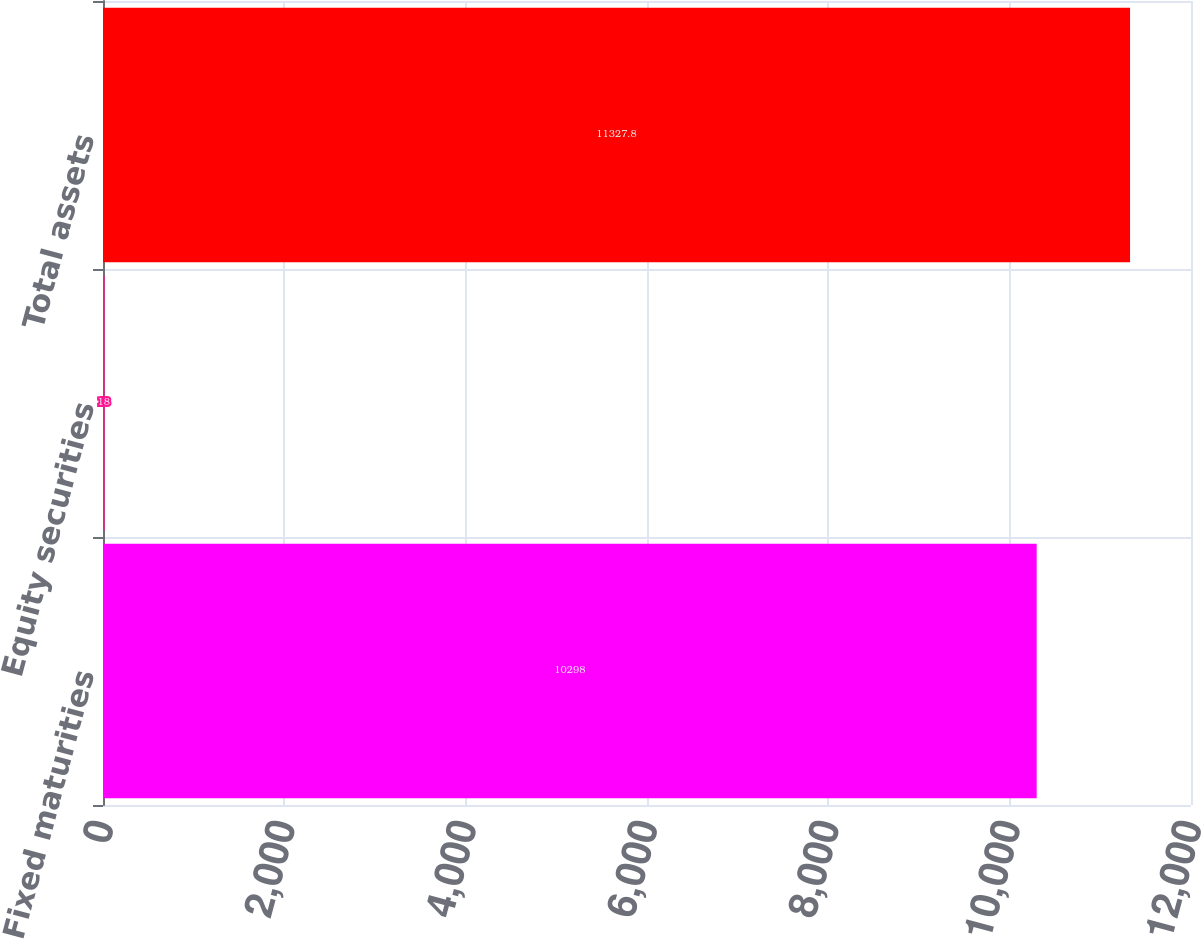Convert chart. <chart><loc_0><loc_0><loc_500><loc_500><bar_chart><fcel>Fixed maturities<fcel>Equity securities<fcel>Total assets<nl><fcel>10298<fcel>18<fcel>11327.8<nl></chart> 